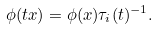Convert formula to latex. <formula><loc_0><loc_0><loc_500><loc_500>\phi ( t x ) = \phi ( x ) \tau _ { i } ( t ) ^ { - 1 } .</formula> 